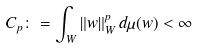Convert formula to latex. <formula><loc_0><loc_0><loc_500><loc_500>C _ { p } \colon = \int _ { W } \| w \| _ { W } ^ { p } \, d \mu ( w ) < \infty</formula> 